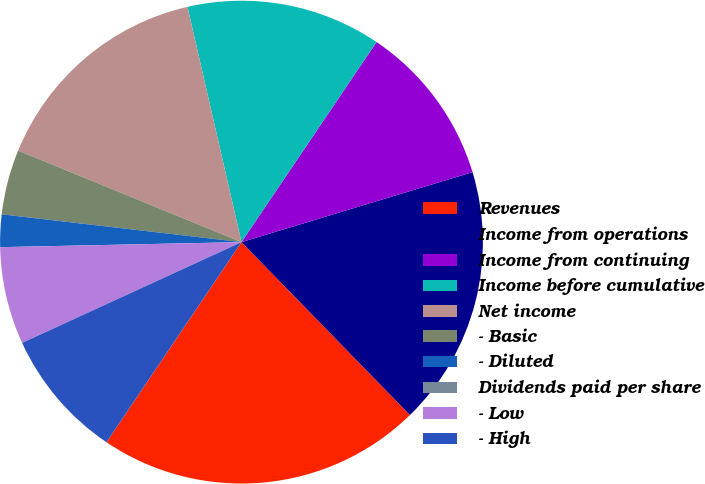Convert chart to OTSL. <chart><loc_0><loc_0><loc_500><loc_500><pie_chart><fcel>Revenues<fcel>Income from operations<fcel>Income from continuing<fcel>Income before cumulative<fcel>Net income<fcel>- Basic<fcel>- Diluted<fcel>Dividends paid per share<fcel>- Low<fcel>- High<nl><fcel>21.74%<fcel>17.39%<fcel>10.87%<fcel>13.04%<fcel>15.22%<fcel>4.35%<fcel>2.17%<fcel>0.0%<fcel>6.52%<fcel>8.7%<nl></chart> 